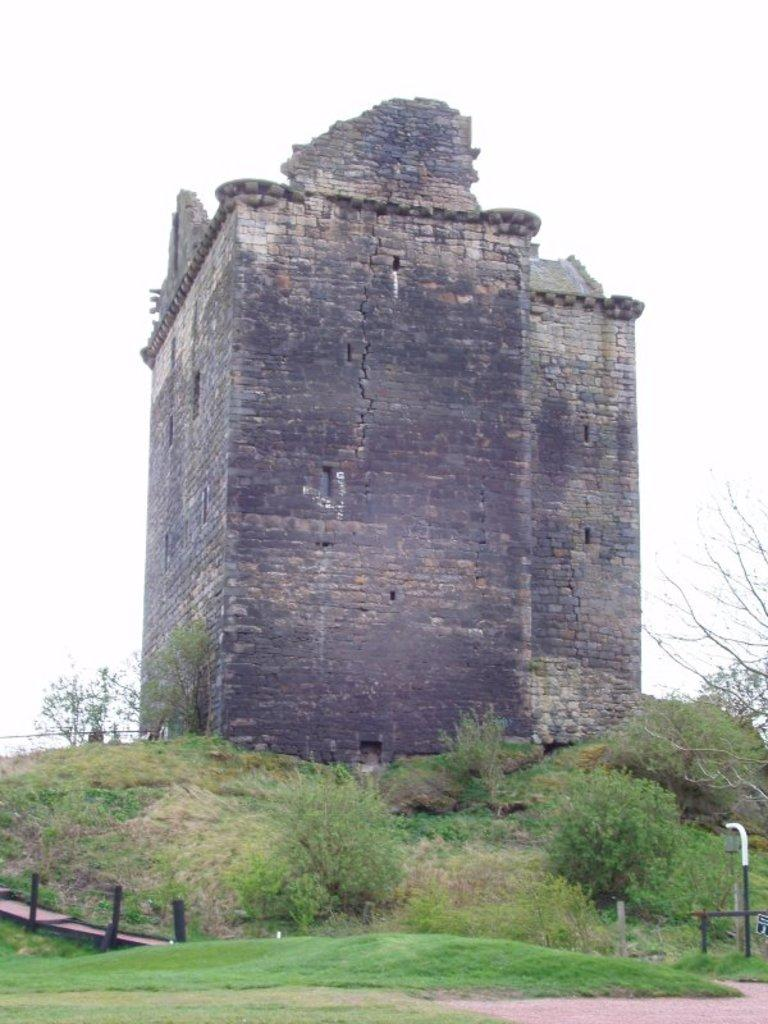What type of structure is visible in the image? There is a building in the image. What type of vegetation can be seen in the image? There are bushes in the image. How does the ticket affect the crying in the image? There is no ticket or crying present in the image; it only features a building and bushes. 